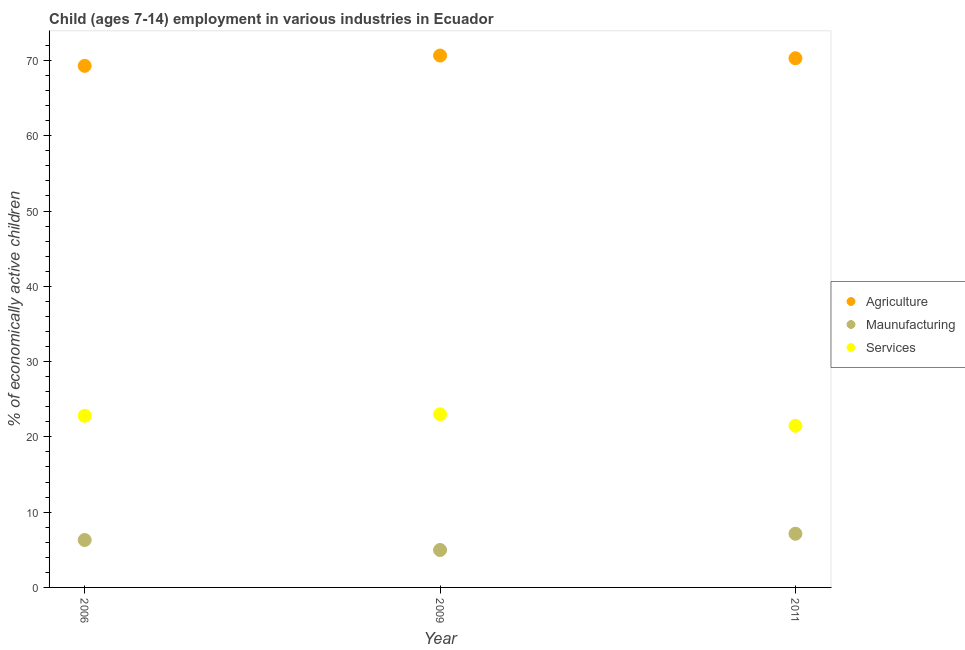Is the number of dotlines equal to the number of legend labels?
Your response must be concise. Yes. What is the percentage of economically active children in agriculture in 2011?
Your response must be concise. 70.29. Across all years, what is the maximum percentage of economically active children in agriculture?
Your answer should be very brief. 70.65. Across all years, what is the minimum percentage of economically active children in manufacturing?
Your response must be concise. 4.97. In which year was the percentage of economically active children in manufacturing minimum?
Make the answer very short. 2009. What is the total percentage of economically active children in services in the graph?
Provide a short and direct response. 67.27. What is the difference between the percentage of economically active children in agriculture in 2006 and that in 2011?
Provide a succinct answer. -1.01. What is the difference between the percentage of economically active children in agriculture in 2011 and the percentage of economically active children in services in 2009?
Give a very brief answer. 47.29. What is the average percentage of economically active children in agriculture per year?
Ensure brevity in your answer.  70.07. In the year 2011, what is the difference between the percentage of economically active children in manufacturing and percentage of economically active children in agriculture?
Provide a succinct answer. -63.16. In how many years, is the percentage of economically active children in manufacturing greater than 12 %?
Offer a terse response. 0. What is the ratio of the percentage of economically active children in manufacturing in 2006 to that in 2009?
Offer a very short reply. 1.27. Is the percentage of economically active children in manufacturing in 2006 less than that in 2009?
Make the answer very short. No. What is the difference between the highest and the second highest percentage of economically active children in services?
Your response must be concise. 0.2. What is the difference between the highest and the lowest percentage of economically active children in manufacturing?
Your answer should be very brief. 2.16. Is it the case that in every year, the sum of the percentage of economically active children in agriculture and percentage of economically active children in manufacturing is greater than the percentage of economically active children in services?
Provide a succinct answer. Yes. Does the percentage of economically active children in agriculture monotonically increase over the years?
Provide a short and direct response. No. Is the percentage of economically active children in agriculture strictly less than the percentage of economically active children in manufacturing over the years?
Ensure brevity in your answer.  No. How many years are there in the graph?
Offer a very short reply. 3. What is the difference between two consecutive major ticks on the Y-axis?
Offer a terse response. 10. Does the graph contain grids?
Your response must be concise. No. Where does the legend appear in the graph?
Offer a very short reply. Center right. How many legend labels are there?
Offer a terse response. 3. What is the title of the graph?
Your answer should be compact. Child (ages 7-14) employment in various industries in Ecuador. What is the label or title of the X-axis?
Provide a succinct answer. Year. What is the label or title of the Y-axis?
Give a very brief answer. % of economically active children. What is the % of economically active children in Agriculture in 2006?
Your response must be concise. 69.28. What is the % of economically active children in Services in 2006?
Your response must be concise. 22.8. What is the % of economically active children of Agriculture in 2009?
Ensure brevity in your answer.  70.65. What is the % of economically active children of Maunufacturing in 2009?
Your answer should be compact. 4.97. What is the % of economically active children in Agriculture in 2011?
Ensure brevity in your answer.  70.29. What is the % of economically active children of Maunufacturing in 2011?
Offer a very short reply. 7.13. What is the % of economically active children in Services in 2011?
Keep it short and to the point. 21.47. Across all years, what is the maximum % of economically active children of Agriculture?
Your answer should be very brief. 70.65. Across all years, what is the maximum % of economically active children in Maunufacturing?
Offer a terse response. 7.13. Across all years, what is the maximum % of economically active children of Services?
Your response must be concise. 23. Across all years, what is the minimum % of economically active children of Agriculture?
Your answer should be very brief. 69.28. Across all years, what is the minimum % of economically active children in Maunufacturing?
Provide a succinct answer. 4.97. Across all years, what is the minimum % of economically active children in Services?
Make the answer very short. 21.47. What is the total % of economically active children of Agriculture in the graph?
Make the answer very short. 210.22. What is the total % of economically active children of Maunufacturing in the graph?
Your answer should be compact. 18.4. What is the total % of economically active children of Services in the graph?
Your answer should be very brief. 67.27. What is the difference between the % of economically active children of Agriculture in 2006 and that in 2009?
Give a very brief answer. -1.37. What is the difference between the % of economically active children of Maunufacturing in 2006 and that in 2009?
Offer a terse response. 1.33. What is the difference between the % of economically active children in Services in 2006 and that in 2009?
Make the answer very short. -0.2. What is the difference between the % of economically active children in Agriculture in 2006 and that in 2011?
Your response must be concise. -1.01. What is the difference between the % of economically active children of Maunufacturing in 2006 and that in 2011?
Your response must be concise. -0.83. What is the difference between the % of economically active children of Services in 2006 and that in 2011?
Ensure brevity in your answer.  1.33. What is the difference between the % of economically active children in Agriculture in 2009 and that in 2011?
Your response must be concise. 0.36. What is the difference between the % of economically active children of Maunufacturing in 2009 and that in 2011?
Ensure brevity in your answer.  -2.16. What is the difference between the % of economically active children in Services in 2009 and that in 2011?
Make the answer very short. 1.53. What is the difference between the % of economically active children in Agriculture in 2006 and the % of economically active children in Maunufacturing in 2009?
Offer a terse response. 64.31. What is the difference between the % of economically active children of Agriculture in 2006 and the % of economically active children of Services in 2009?
Your answer should be compact. 46.28. What is the difference between the % of economically active children in Maunufacturing in 2006 and the % of economically active children in Services in 2009?
Make the answer very short. -16.7. What is the difference between the % of economically active children of Agriculture in 2006 and the % of economically active children of Maunufacturing in 2011?
Offer a terse response. 62.15. What is the difference between the % of economically active children in Agriculture in 2006 and the % of economically active children in Services in 2011?
Provide a short and direct response. 47.81. What is the difference between the % of economically active children in Maunufacturing in 2006 and the % of economically active children in Services in 2011?
Offer a very short reply. -15.17. What is the difference between the % of economically active children in Agriculture in 2009 and the % of economically active children in Maunufacturing in 2011?
Offer a very short reply. 63.52. What is the difference between the % of economically active children in Agriculture in 2009 and the % of economically active children in Services in 2011?
Provide a short and direct response. 49.18. What is the difference between the % of economically active children of Maunufacturing in 2009 and the % of economically active children of Services in 2011?
Keep it short and to the point. -16.5. What is the average % of economically active children in Agriculture per year?
Offer a terse response. 70.07. What is the average % of economically active children of Maunufacturing per year?
Provide a short and direct response. 6.13. What is the average % of economically active children of Services per year?
Provide a succinct answer. 22.42. In the year 2006, what is the difference between the % of economically active children in Agriculture and % of economically active children in Maunufacturing?
Give a very brief answer. 62.98. In the year 2006, what is the difference between the % of economically active children in Agriculture and % of economically active children in Services?
Give a very brief answer. 46.48. In the year 2006, what is the difference between the % of economically active children of Maunufacturing and % of economically active children of Services?
Ensure brevity in your answer.  -16.5. In the year 2009, what is the difference between the % of economically active children of Agriculture and % of economically active children of Maunufacturing?
Ensure brevity in your answer.  65.68. In the year 2009, what is the difference between the % of economically active children of Agriculture and % of economically active children of Services?
Provide a short and direct response. 47.65. In the year 2009, what is the difference between the % of economically active children in Maunufacturing and % of economically active children in Services?
Offer a very short reply. -18.03. In the year 2011, what is the difference between the % of economically active children of Agriculture and % of economically active children of Maunufacturing?
Your answer should be compact. 63.16. In the year 2011, what is the difference between the % of economically active children of Agriculture and % of economically active children of Services?
Offer a very short reply. 48.82. In the year 2011, what is the difference between the % of economically active children in Maunufacturing and % of economically active children in Services?
Ensure brevity in your answer.  -14.34. What is the ratio of the % of economically active children of Agriculture in 2006 to that in 2009?
Provide a short and direct response. 0.98. What is the ratio of the % of economically active children of Maunufacturing in 2006 to that in 2009?
Ensure brevity in your answer.  1.27. What is the ratio of the % of economically active children of Services in 2006 to that in 2009?
Make the answer very short. 0.99. What is the ratio of the % of economically active children in Agriculture in 2006 to that in 2011?
Your answer should be compact. 0.99. What is the ratio of the % of economically active children in Maunufacturing in 2006 to that in 2011?
Your response must be concise. 0.88. What is the ratio of the % of economically active children of Services in 2006 to that in 2011?
Your response must be concise. 1.06. What is the ratio of the % of economically active children of Agriculture in 2009 to that in 2011?
Provide a succinct answer. 1.01. What is the ratio of the % of economically active children in Maunufacturing in 2009 to that in 2011?
Give a very brief answer. 0.7. What is the ratio of the % of economically active children in Services in 2009 to that in 2011?
Your response must be concise. 1.07. What is the difference between the highest and the second highest % of economically active children in Agriculture?
Make the answer very short. 0.36. What is the difference between the highest and the second highest % of economically active children in Maunufacturing?
Offer a terse response. 0.83. What is the difference between the highest and the lowest % of economically active children in Agriculture?
Offer a very short reply. 1.37. What is the difference between the highest and the lowest % of economically active children in Maunufacturing?
Give a very brief answer. 2.16. What is the difference between the highest and the lowest % of economically active children of Services?
Make the answer very short. 1.53. 